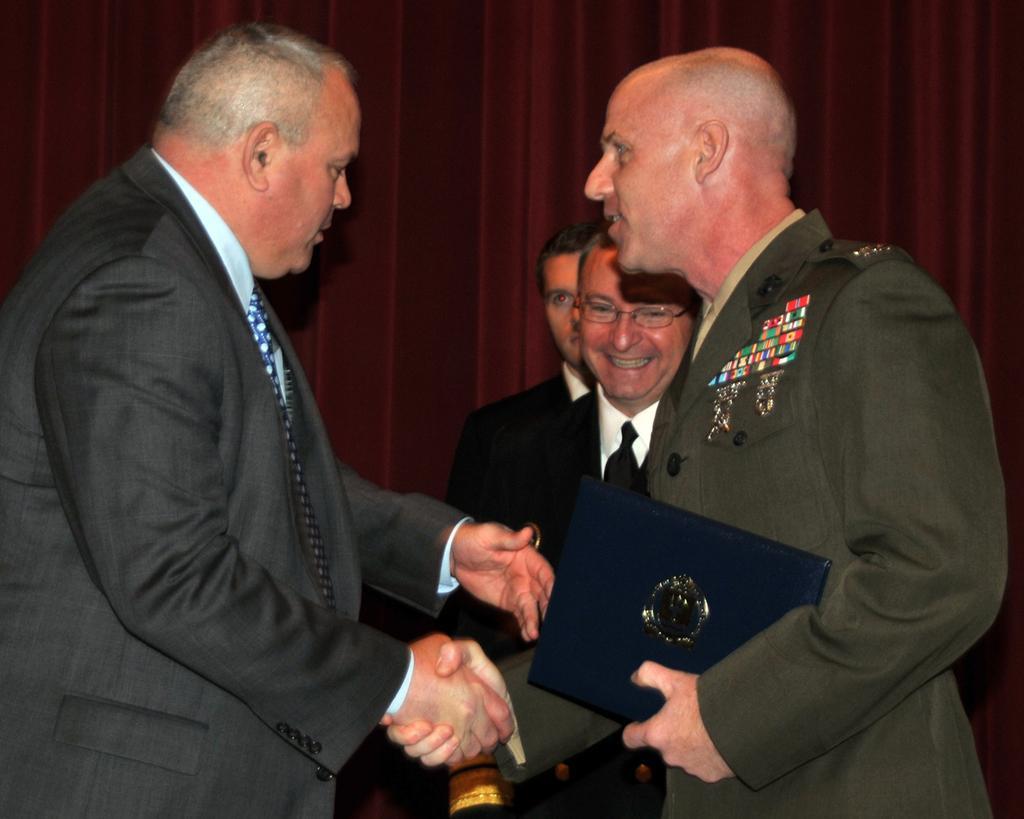Can you describe this image briefly? In this image I can see four people with different color dresses. I can see one person is holding the blue color object. In the back I can see the maroon color curtain. 